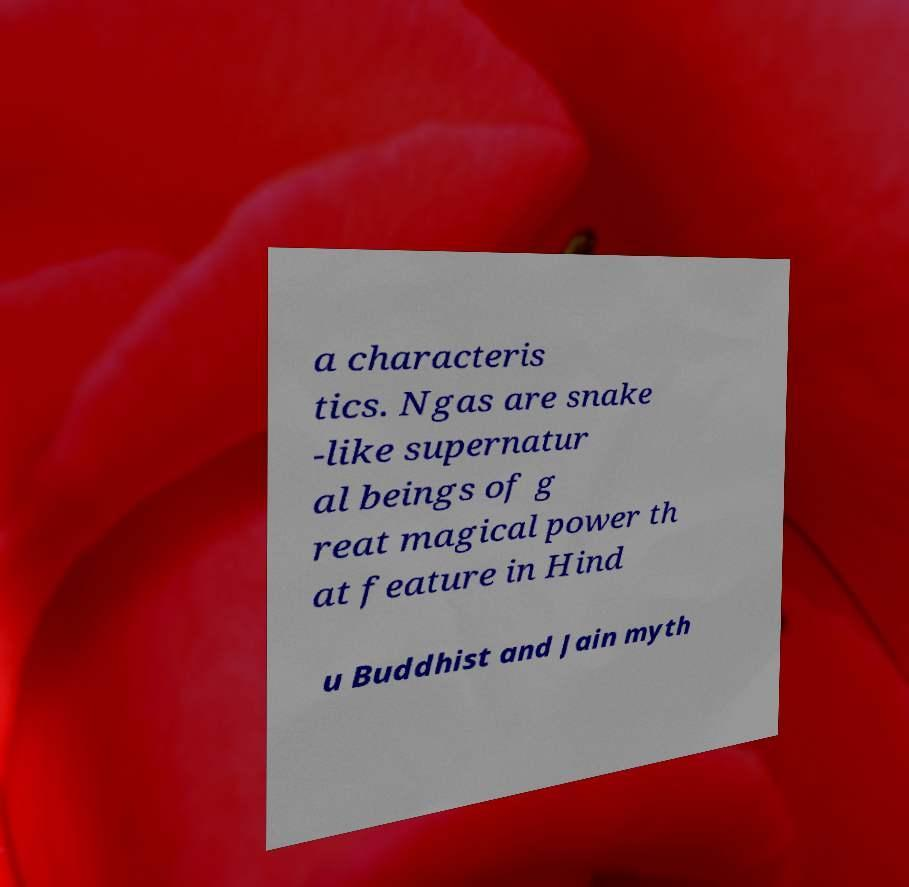Can you read and provide the text displayed in the image?This photo seems to have some interesting text. Can you extract and type it out for me? a characteris tics. Ngas are snake -like supernatur al beings of g reat magical power th at feature in Hind u Buddhist and Jain myth 